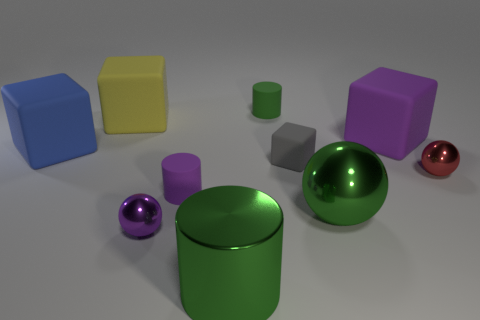What number of other things are the same shape as the tiny green object?
Keep it short and to the point. 2. Are the small block and the tiny object that is left of the small purple rubber cylinder made of the same material?
Keep it short and to the point. No. Are there fewer cubes in front of the large blue rubber object than cylinders that are behind the small purple rubber thing?
Offer a terse response. No. What number of green spheres are the same material as the small green thing?
Make the answer very short. 0. Are there any red spheres that are on the left side of the ball on the left side of the purple matte cylinder that is behind the green metal ball?
Give a very brief answer. No. How many cylinders are purple metallic objects or big green metallic things?
Your answer should be very brief. 1. Do the small purple metal object and the small metallic object that is behind the small purple matte object have the same shape?
Your answer should be compact. Yes. Are there fewer green metallic balls to the right of the tiny red ball than large yellow blocks?
Your response must be concise. Yes. There is a small purple metallic thing; are there any tiny purple balls right of it?
Offer a very short reply. No. Are there any big gray shiny objects that have the same shape as the small gray thing?
Your response must be concise. No. 